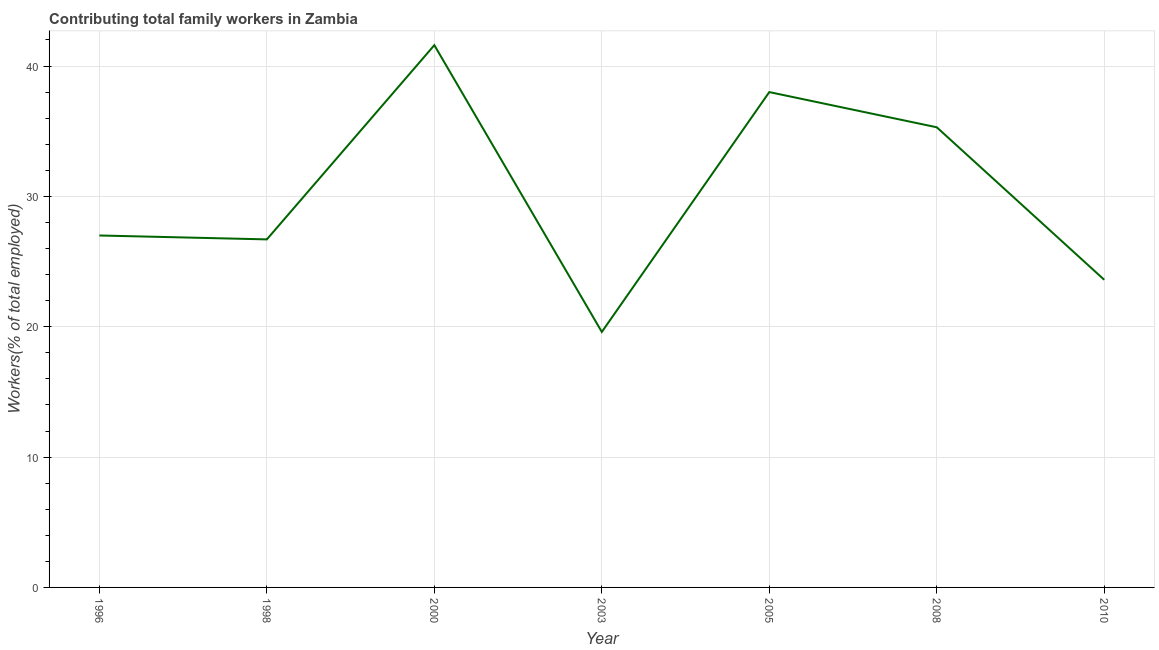What is the contributing family workers in 1998?
Keep it short and to the point. 26.7. Across all years, what is the maximum contributing family workers?
Ensure brevity in your answer.  41.6. Across all years, what is the minimum contributing family workers?
Offer a terse response. 19.6. In which year was the contributing family workers maximum?
Give a very brief answer. 2000. What is the sum of the contributing family workers?
Make the answer very short. 211.8. What is the difference between the contributing family workers in 1998 and 2005?
Your response must be concise. -11.3. What is the average contributing family workers per year?
Give a very brief answer. 30.26. In how many years, is the contributing family workers greater than 20 %?
Offer a very short reply. 6. Do a majority of the years between 1998 and 2010 (inclusive) have contributing family workers greater than 20 %?
Ensure brevity in your answer.  Yes. What is the ratio of the contributing family workers in 2000 to that in 2003?
Keep it short and to the point. 2.12. What is the difference between the highest and the second highest contributing family workers?
Your answer should be very brief. 3.6. What is the difference between the highest and the lowest contributing family workers?
Give a very brief answer. 22. In how many years, is the contributing family workers greater than the average contributing family workers taken over all years?
Your answer should be very brief. 3. Does the contributing family workers monotonically increase over the years?
Offer a very short reply. No. Does the graph contain grids?
Give a very brief answer. Yes. What is the title of the graph?
Offer a very short reply. Contributing total family workers in Zambia. What is the label or title of the X-axis?
Keep it short and to the point. Year. What is the label or title of the Y-axis?
Give a very brief answer. Workers(% of total employed). What is the Workers(% of total employed) in 1996?
Your response must be concise. 27. What is the Workers(% of total employed) of 1998?
Keep it short and to the point. 26.7. What is the Workers(% of total employed) in 2000?
Ensure brevity in your answer.  41.6. What is the Workers(% of total employed) in 2003?
Keep it short and to the point. 19.6. What is the Workers(% of total employed) of 2008?
Your answer should be compact. 35.3. What is the Workers(% of total employed) of 2010?
Make the answer very short. 23.6. What is the difference between the Workers(% of total employed) in 1996 and 2000?
Provide a short and direct response. -14.6. What is the difference between the Workers(% of total employed) in 1996 and 2003?
Offer a terse response. 7.4. What is the difference between the Workers(% of total employed) in 1996 and 2005?
Offer a terse response. -11. What is the difference between the Workers(% of total employed) in 1996 and 2010?
Provide a succinct answer. 3.4. What is the difference between the Workers(% of total employed) in 1998 and 2000?
Offer a terse response. -14.9. What is the difference between the Workers(% of total employed) in 1998 and 2008?
Your answer should be compact. -8.6. What is the difference between the Workers(% of total employed) in 1998 and 2010?
Provide a short and direct response. 3.1. What is the difference between the Workers(% of total employed) in 2000 and 2008?
Give a very brief answer. 6.3. What is the difference between the Workers(% of total employed) in 2003 and 2005?
Offer a terse response. -18.4. What is the difference between the Workers(% of total employed) in 2003 and 2008?
Offer a terse response. -15.7. What is the difference between the Workers(% of total employed) in 2003 and 2010?
Keep it short and to the point. -4. What is the difference between the Workers(% of total employed) in 2005 and 2010?
Your response must be concise. 14.4. What is the difference between the Workers(% of total employed) in 2008 and 2010?
Your answer should be compact. 11.7. What is the ratio of the Workers(% of total employed) in 1996 to that in 1998?
Your answer should be very brief. 1.01. What is the ratio of the Workers(% of total employed) in 1996 to that in 2000?
Your answer should be compact. 0.65. What is the ratio of the Workers(% of total employed) in 1996 to that in 2003?
Offer a very short reply. 1.38. What is the ratio of the Workers(% of total employed) in 1996 to that in 2005?
Your answer should be compact. 0.71. What is the ratio of the Workers(% of total employed) in 1996 to that in 2008?
Your answer should be very brief. 0.77. What is the ratio of the Workers(% of total employed) in 1996 to that in 2010?
Offer a terse response. 1.14. What is the ratio of the Workers(% of total employed) in 1998 to that in 2000?
Your answer should be very brief. 0.64. What is the ratio of the Workers(% of total employed) in 1998 to that in 2003?
Ensure brevity in your answer.  1.36. What is the ratio of the Workers(% of total employed) in 1998 to that in 2005?
Offer a very short reply. 0.7. What is the ratio of the Workers(% of total employed) in 1998 to that in 2008?
Give a very brief answer. 0.76. What is the ratio of the Workers(% of total employed) in 1998 to that in 2010?
Provide a succinct answer. 1.13. What is the ratio of the Workers(% of total employed) in 2000 to that in 2003?
Ensure brevity in your answer.  2.12. What is the ratio of the Workers(% of total employed) in 2000 to that in 2005?
Provide a short and direct response. 1.09. What is the ratio of the Workers(% of total employed) in 2000 to that in 2008?
Ensure brevity in your answer.  1.18. What is the ratio of the Workers(% of total employed) in 2000 to that in 2010?
Ensure brevity in your answer.  1.76. What is the ratio of the Workers(% of total employed) in 2003 to that in 2005?
Your answer should be very brief. 0.52. What is the ratio of the Workers(% of total employed) in 2003 to that in 2008?
Provide a succinct answer. 0.56. What is the ratio of the Workers(% of total employed) in 2003 to that in 2010?
Make the answer very short. 0.83. What is the ratio of the Workers(% of total employed) in 2005 to that in 2008?
Your answer should be compact. 1.08. What is the ratio of the Workers(% of total employed) in 2005 to that in 2010?
Make the answer very short. 1.61. What is the ratio of the Workers(% of total employed) in 2008 to that in 2010?
Provide a succinct answer. 1.5. 